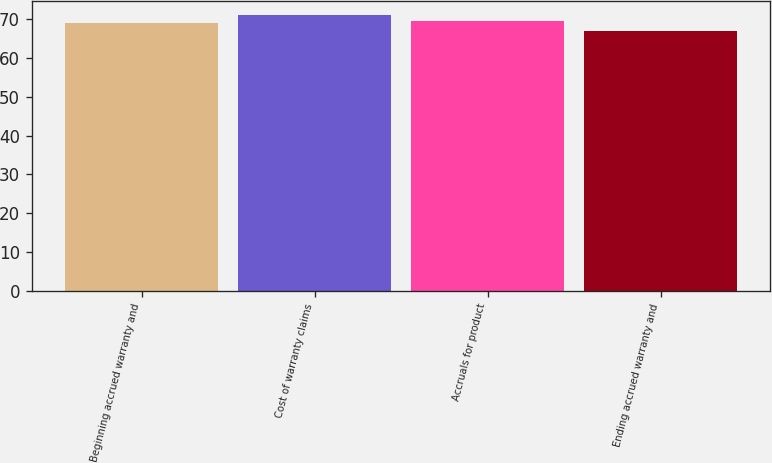<chart> <loc_0><loc_0><loc_500><loc_500><bar_chart><fcel>Beginning accrued warranty and<fcel>Cost of warranty claims<fcel>Accruals for product<fcel>Ending accrued warranty and<nl><fcel>69<fcel>71<fcel>69.4<fcel>67<nl></chart> 